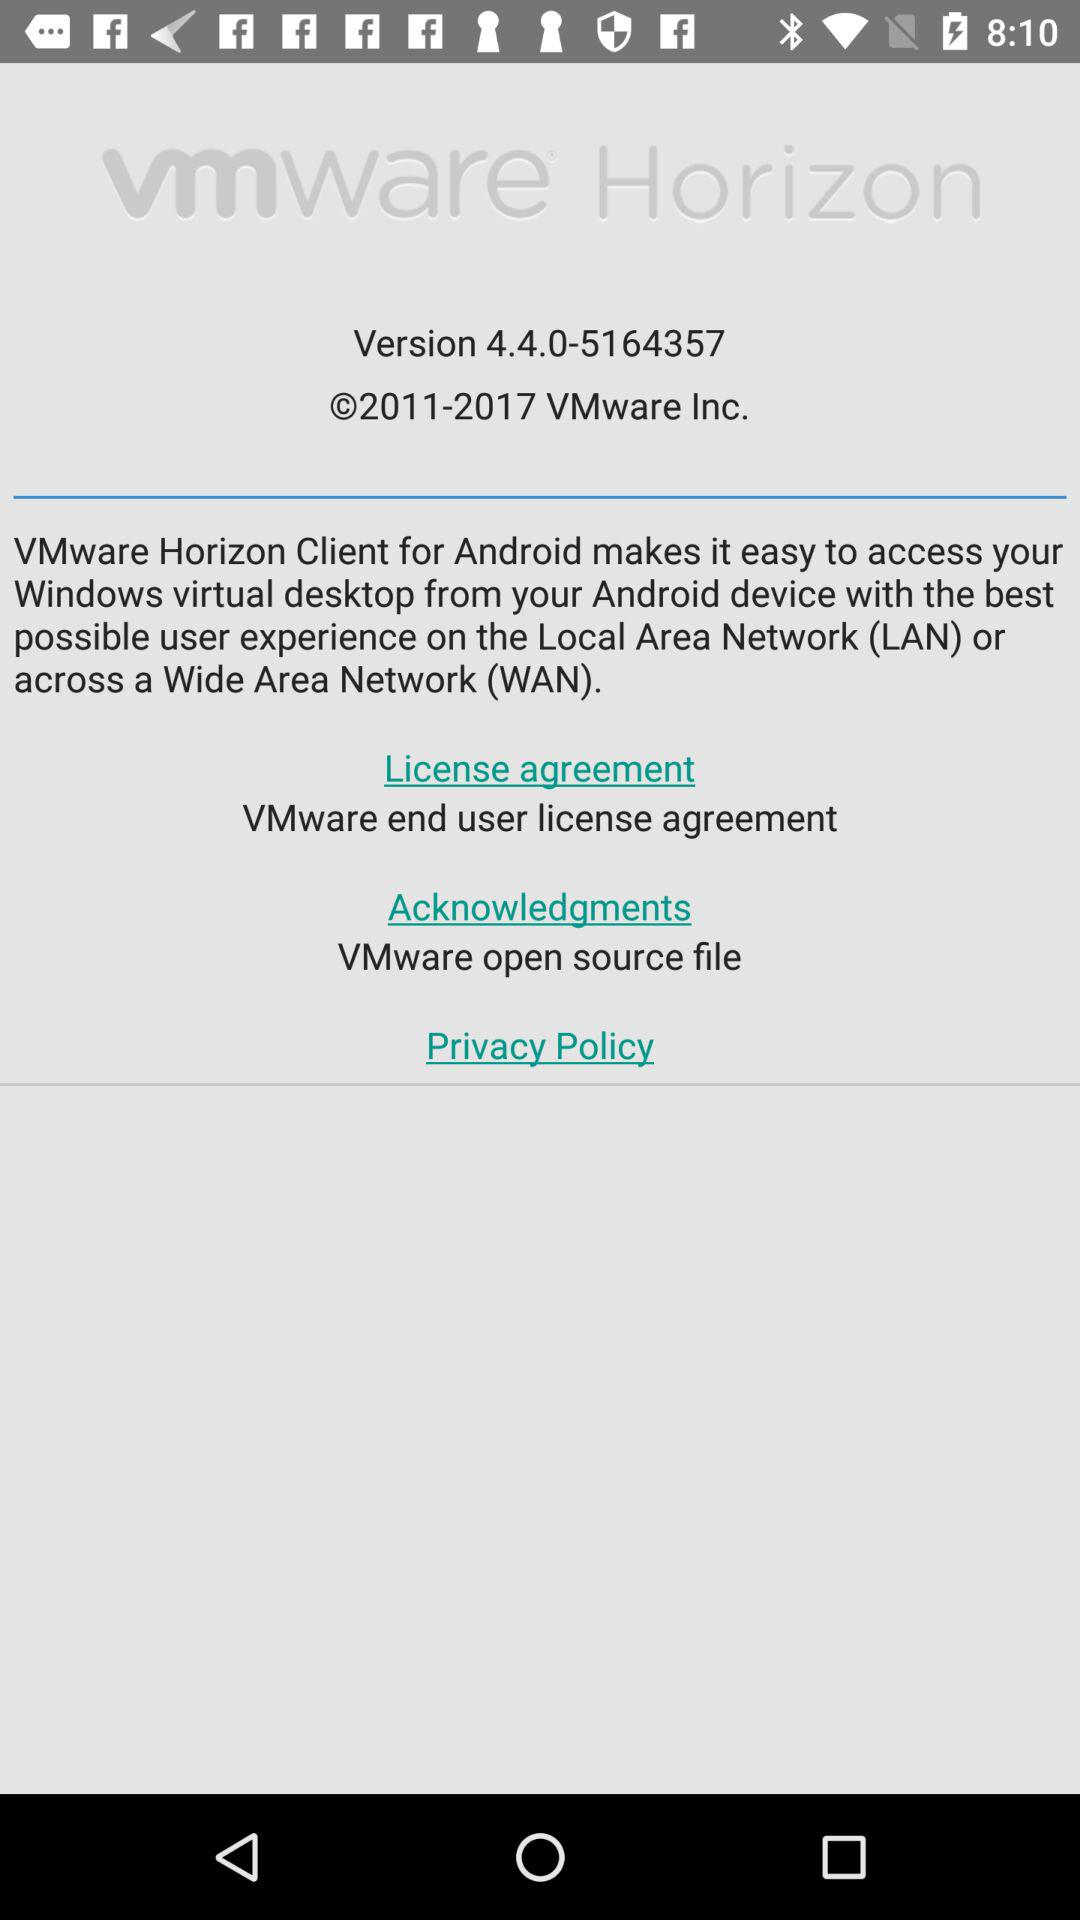What is the version? The version is 4.4.0-5164357. 